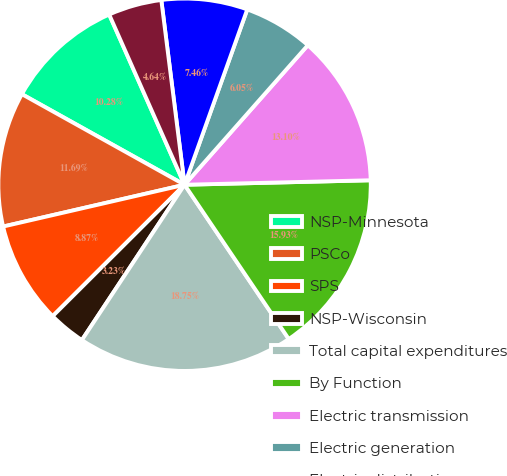Convert chart to OTSL. <chart><loc_0><loc_0><loc_500><loc_500><pie_chart><fcel>NSP-Minnesota<fcel>PSCo<fcel>SPS<fcel>NSP-Wisconsin<fcel>Total capital expenditures<fcel>By Function<fcel>Electric transmission<fcel>Electric generation<fcel>Electric distribution<fcel>Natural gas<nl><fcel>10.28%<fcel>11.69%<fcel>8.87%<fcel>3.23%<fcel>18.75%<fcel>15.93%<fcel>13.1%<fcel>6.05%<fcel>7.46%<fcel>4.64%<nl></chart> 